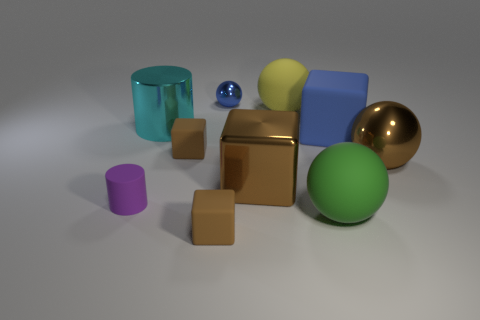What is the shape of the small brown rubber thing behind the big metallic cube?
Ensure brevity in your answer.  Cube. What is the size of the brown block that is behind the brown block that is right of the tiny thing in front of the green ball?
Your response must be concise. Small. Is the big yellow matte thing the same shape as the large cyan metallic object?
Ensure brevity in your answer.  No. There is a matte thing that is behind the green matte sphere and in front of the brown metal cube; what is its size?
Give a very brief answer. Small. There is a blue thing that is the same shape as the green matte thing; what is it made of?
Your response must be concise. Metal. There is a blue ball that is behind the cylinder that is in front of the big metal cylinder; what is its material?
Make the answer very short. Metal. Does the large green matte object have the same shape as the large brown metal object that is to the left of the big green thing?
Provide a short and direct response. No. How many matte things are large brown spheres or green cubes?
Ensure brevity in your answer.  0. What color is the large rubber ball behind the small brown object that is behind the brown cube right of the small metal sphere?
Provide a short and direct response. Yellow. How many other things are made of the same material as the blue ball?
Provide a succinct answer. 3. 